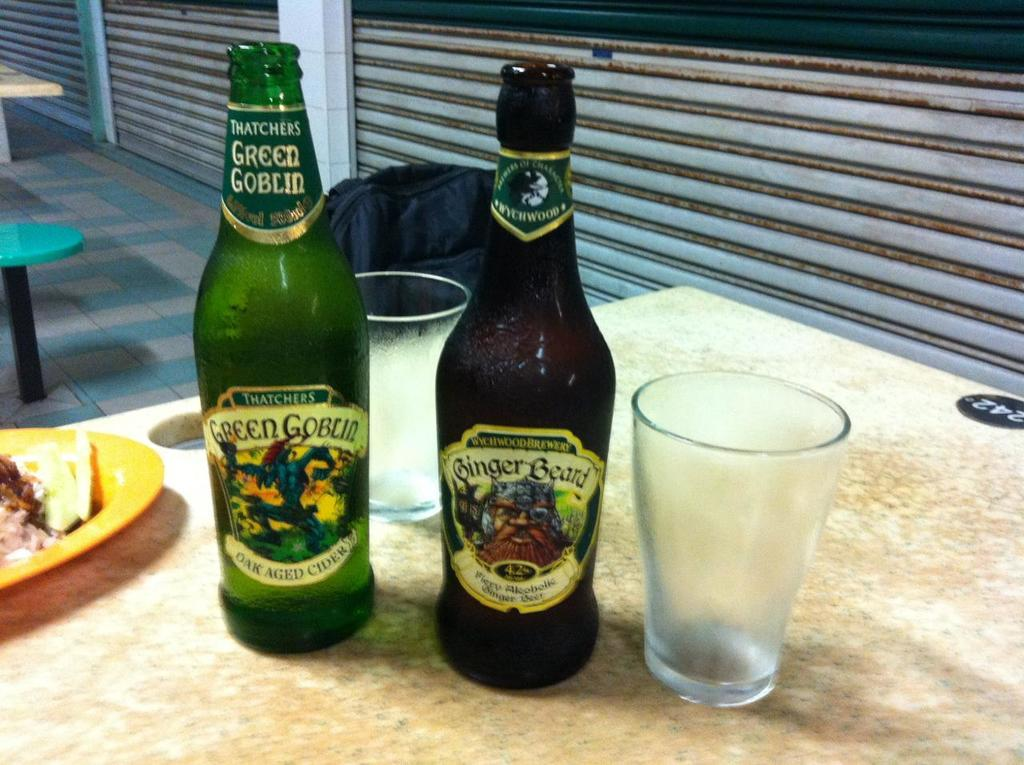<image>
Share a concise interpretation of the image provided. Two bottles, labelled Green Goblin and Ginger Beer, stand next to an empy glass. 